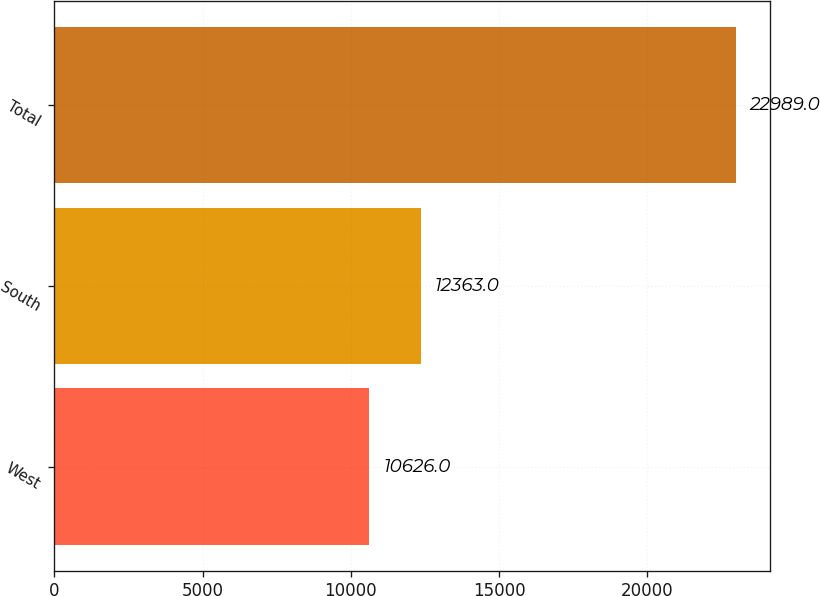<chart> <loc_0><loc_0><loc_500><loc_500><bar_chart><fcel>West<fcel>South<fcel>Total<nl><fcel>10626<fcel>12363<fcel>22989<nl></chart> 